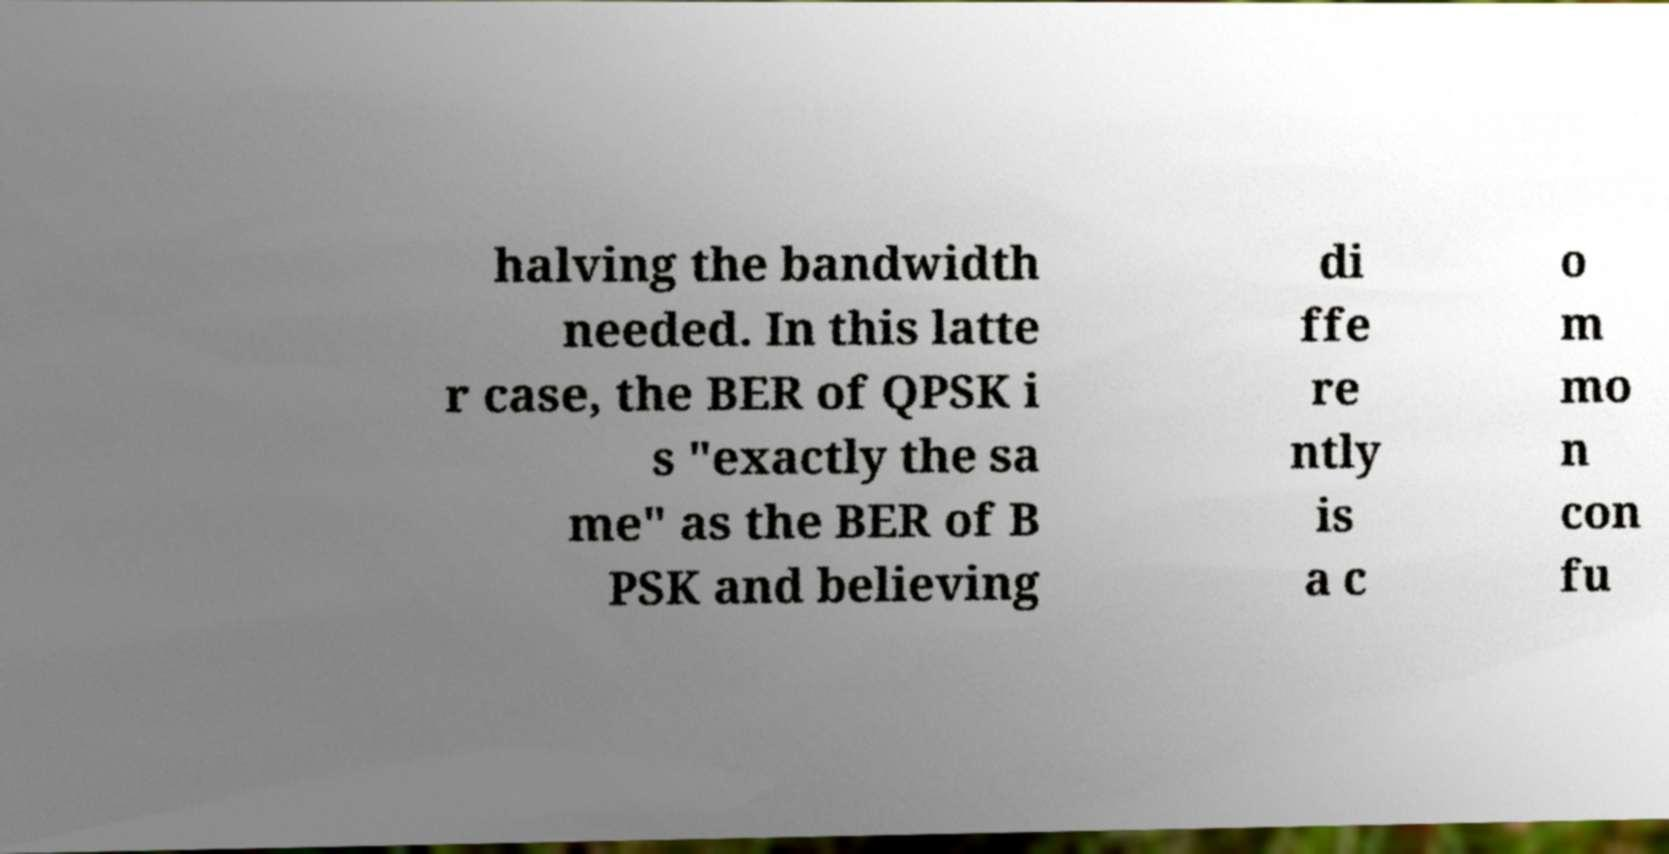Can you accurately transcribe the text from the provided image for me? halving the bandwidth needed. In this latte r case, the BER of QPSK i s "exactly the sa me" as the BER of B PSK and believing di ffe re ntly is a c o m mo n con fu 